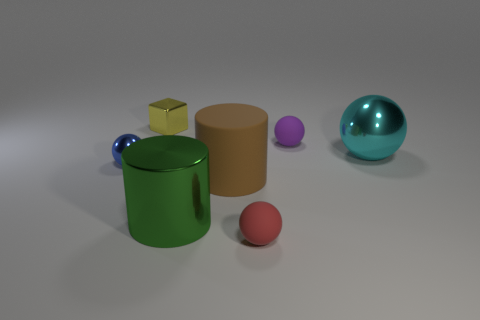Is the number of metal balls that are on the right side of the tiny blue ball greater than the number of tiny matte cubes?
Provide a succinct answer. Yes. What shape is the tiny matte object behind the cyan shiny thing?
Ensure brevity in your answer.  Sphere. How many other things are there of the same shape as the tiny red object?
Make the answer very short. 3. Is the material of the big brown thing that is in front of the cyan thing the same as the tiny purple sphere?
Make the answer very short. Yes. Are there the same number of brown matte cylinders behind the tiny shiny sphere and purple balls that are to the right of the small purple matte sphere?
Offer a terse response. Yes. How big is the metal ball that is on the right side of the large brown cylinder?
Give a very brief answer. Large. Is there a green cylinder that has the same material as the blue object?
Your answer should be compact. Yes. Is the color of the metallic ball that is to the left of the large cyan object the same as the tiny cube?
Provide a succinct answer. No. Are there the same number of big metallic balls on the left side of the purple thing and red matte balls?
Your answer should be compact. No. Do the red object and the purple rubber ball have the same size?
Your response must be concise. Yes. 